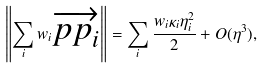<formula> <loc_0><loc_0><loc_500><loc_500>\left \| \sum _ { i } w _ { i } \overrightarrow { { p p } _ { i } } \right \| = \sum _ { i } \frac { w _ { i } \kappa _ { i } \eta _ { i } ^ { 2 } } 2 + O ( \eta ^ { 3 } ) ,</formula> 